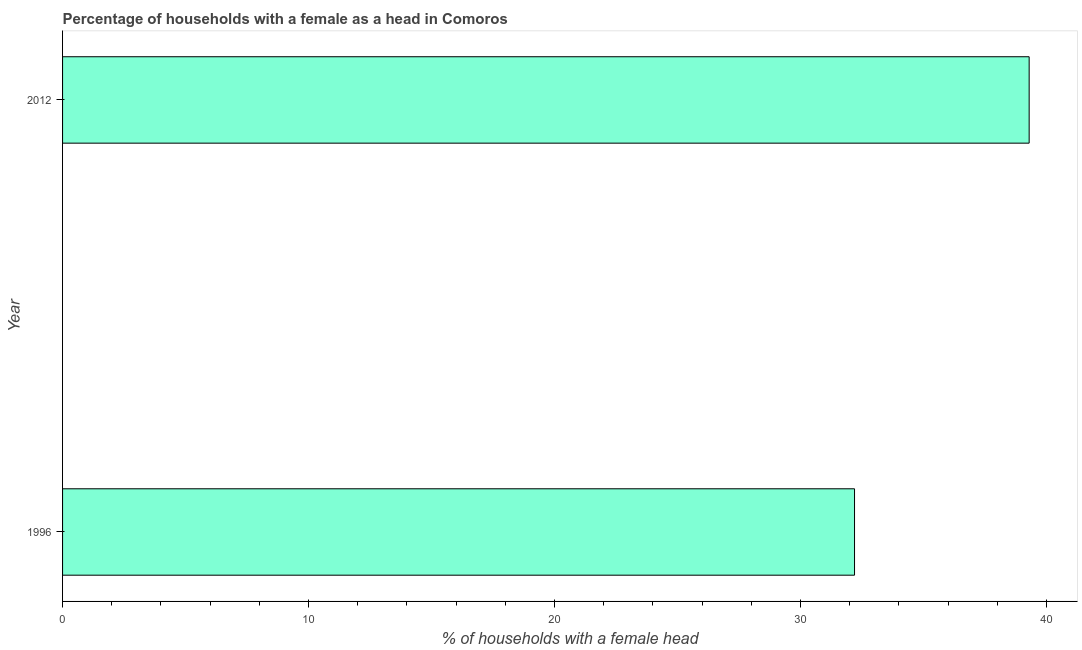What is the title of the graph?
Provide a short and direct response. Percentage of households with a female as a head in Comoros. What is the label or title of the X-axis?
Offer a very short reply. % of households with a female head. What is the label or title of the Y-axis?
Offer a terse response. Year. What is the number of female supervised households in 2012?
Offer a terse response. 39.3. Across all years, what is the maximum number of female supervised households?
Provide a succinct answer. 39.3. Across all years, what is the minimum number of female supervised households?
Provide a succinct answer. 32.2. In which year was the number of female supervised households maximum?
Provide a short and direct response. 2012. In which year was the number of female supervised households minimum?
Provide a short and direct response. 1996. What is the sum of the number of female supervised households?
Offer a terse response. 71.5. What is the average number of female supervised households per year?
Make the answer very short. 35.75. What is the median number of female supervised households?
Provide a short and direct response. 35.75. In how many years, is the number of female supervised households greater than 34 %?
Provide a succinct answer. 1. Do a majority of the years between 1996 and 2012 (inclusive) have number of female supervised households greater than 24 %?
Make the answer very short. Yes. What is the ratio of the number of female supervised households in 1996 to that in 2012?
Your answer should be compact. 0.82. Are all the bars in the graph horizontal?
Your response must be concise. Yes. What is the difference between two consecutive major ticks on the X-axis?
Ensure brevity in your answer.  10. Are the values on the major ticks of X-axis written in scientific E-notation?
Give a very brief answer. No. What is the % of households with a female head of 1996?
Make the answer very short. 32.2. What is the % of households with a female head in 2012?
Ensure brevity in your answer.  39.3. What is the ratio of the % of households with a female head in 1996 to that in 2012?
Your answer should be compact. 0.82. 